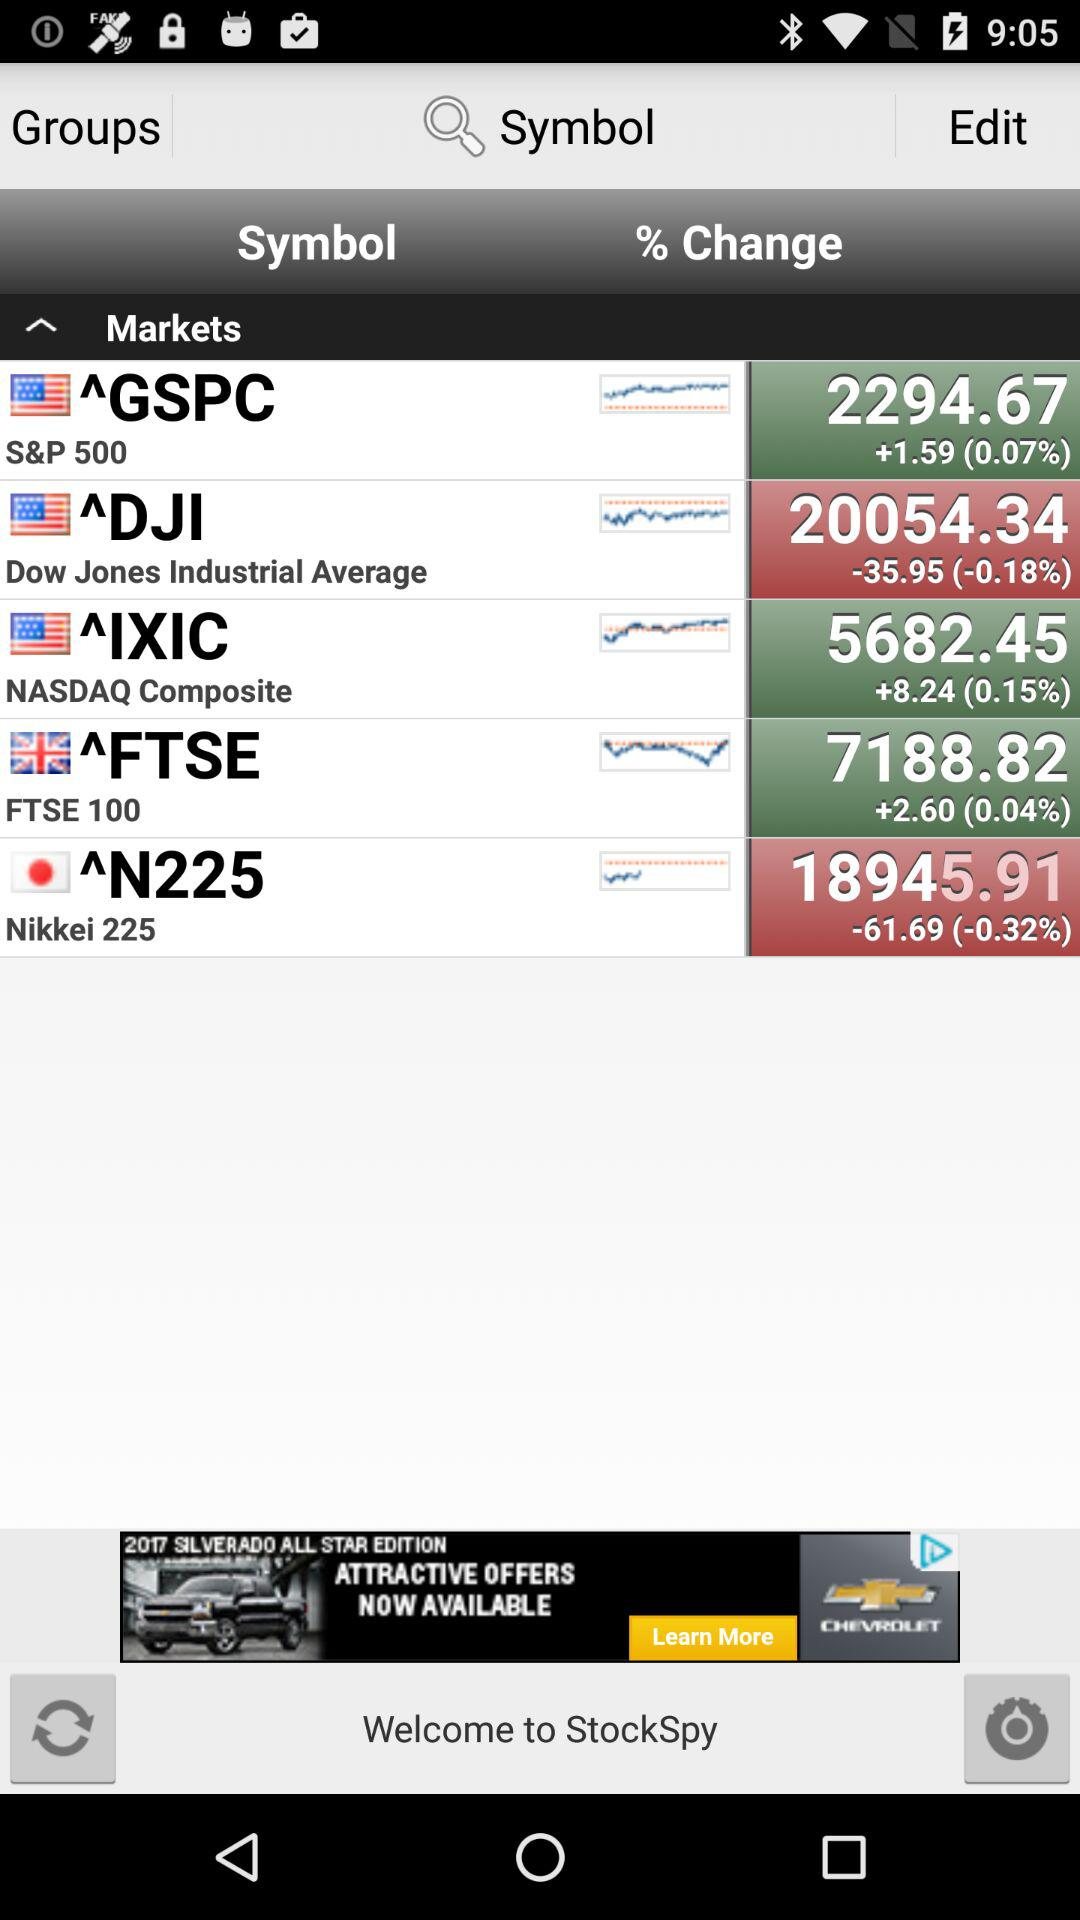What is the stock price of the GSPC? The stock price of the GSPC is 2294.67. 